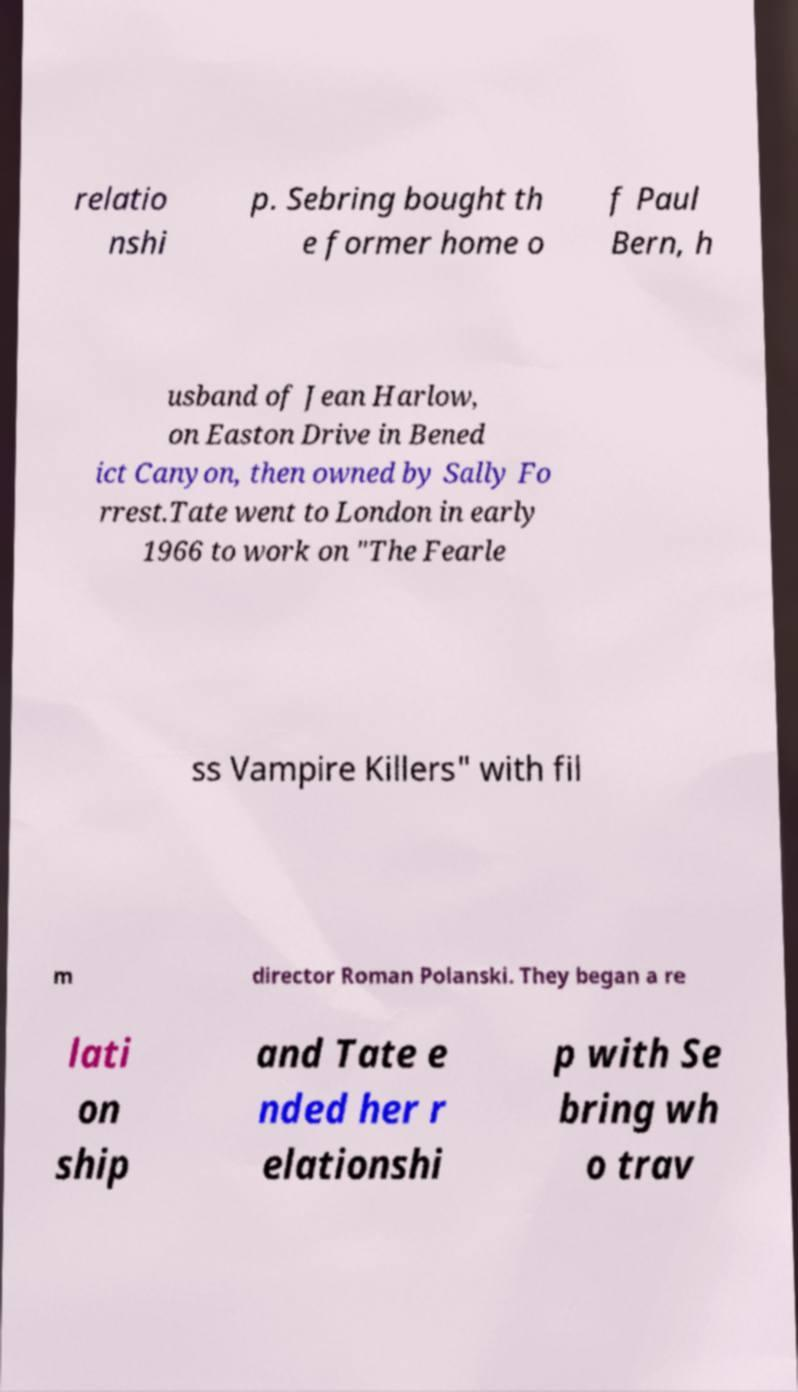I need the written content from this picture converted into text. Can you do that? relatio nshi p. Sebring bought th e former home o f Paul Bern, h usband of Jean Harlow, on Easton Drive in Bened ict Canyon, then owned by Sally Fo rrest.Tate went to London in early 1966 to work on "The Fearle ss Vampire Killers" with fil m director Roman Polanski. They began a re lati on ship and Tate e nded her r elationshi p with Se bring wh o trav 